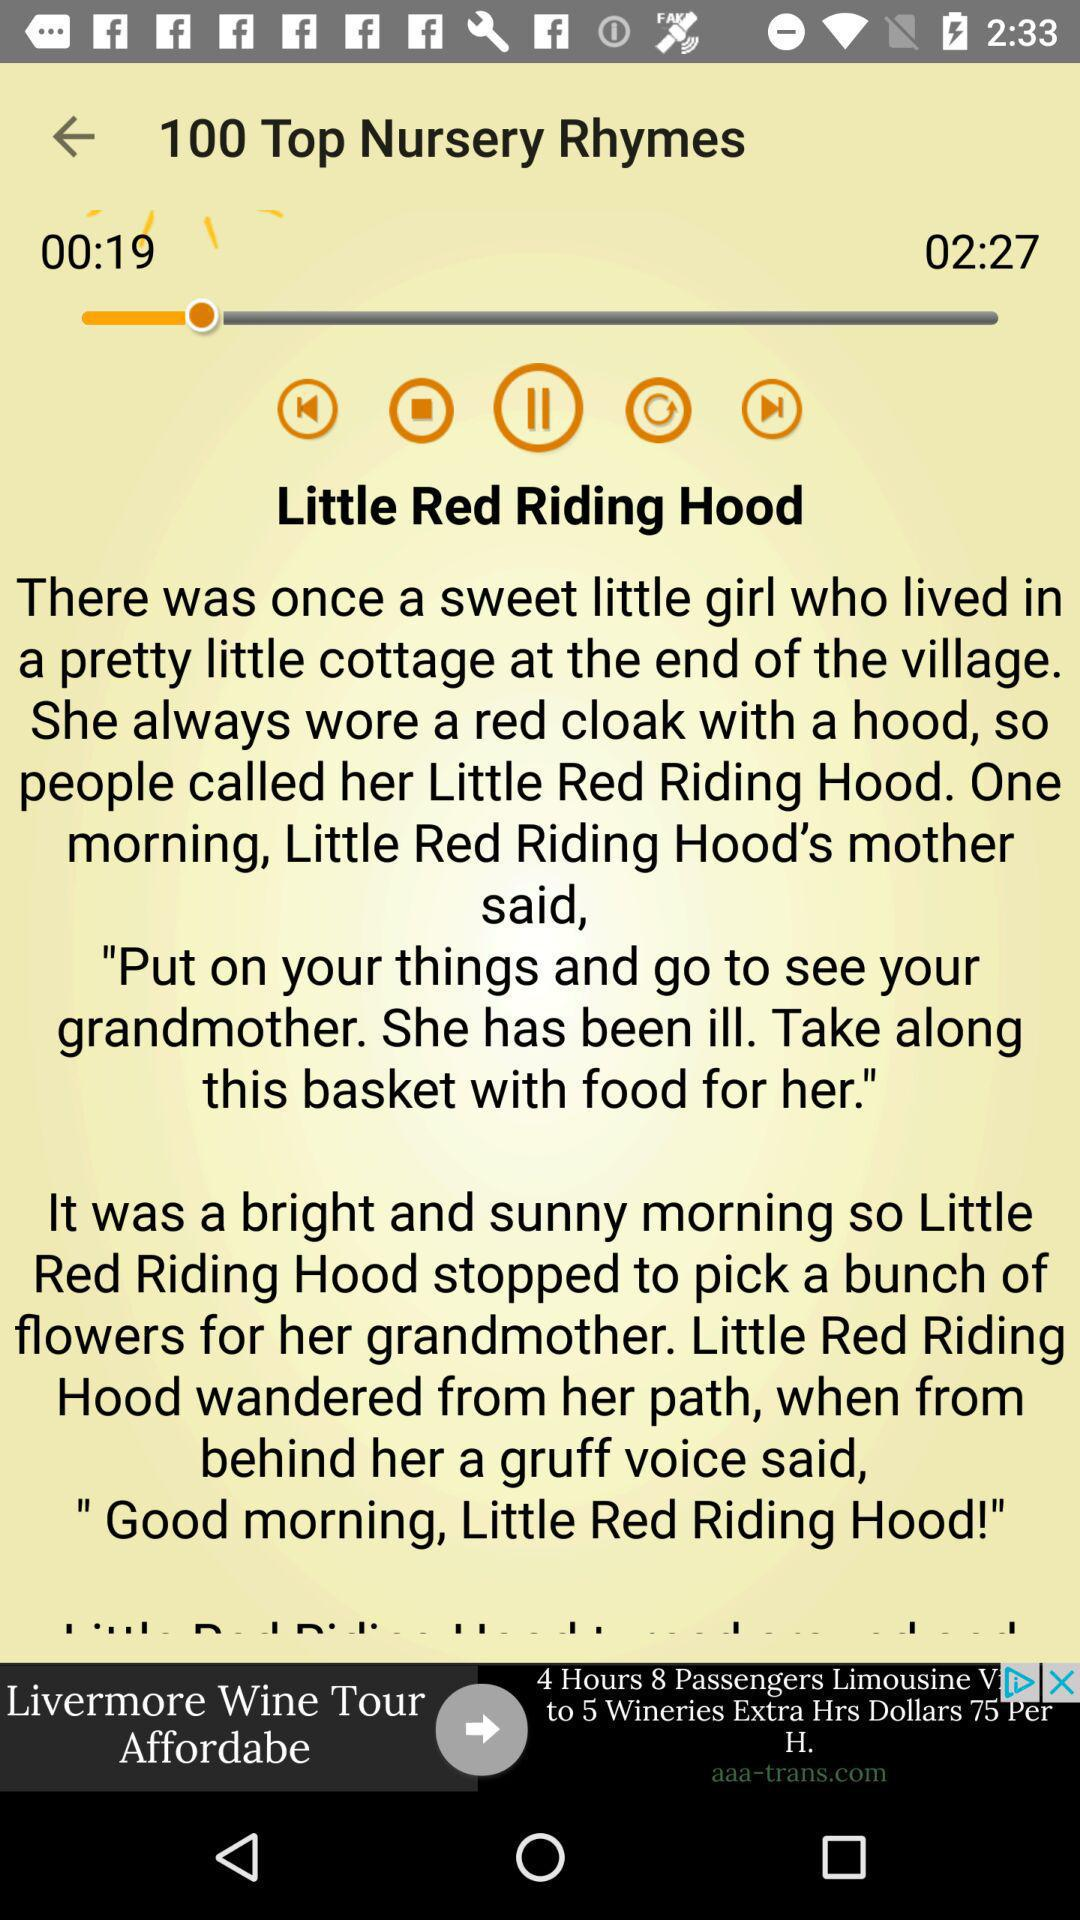What is the duration of the rhyme? The duration of the rhyme is 2 minutes 27 seconds. 